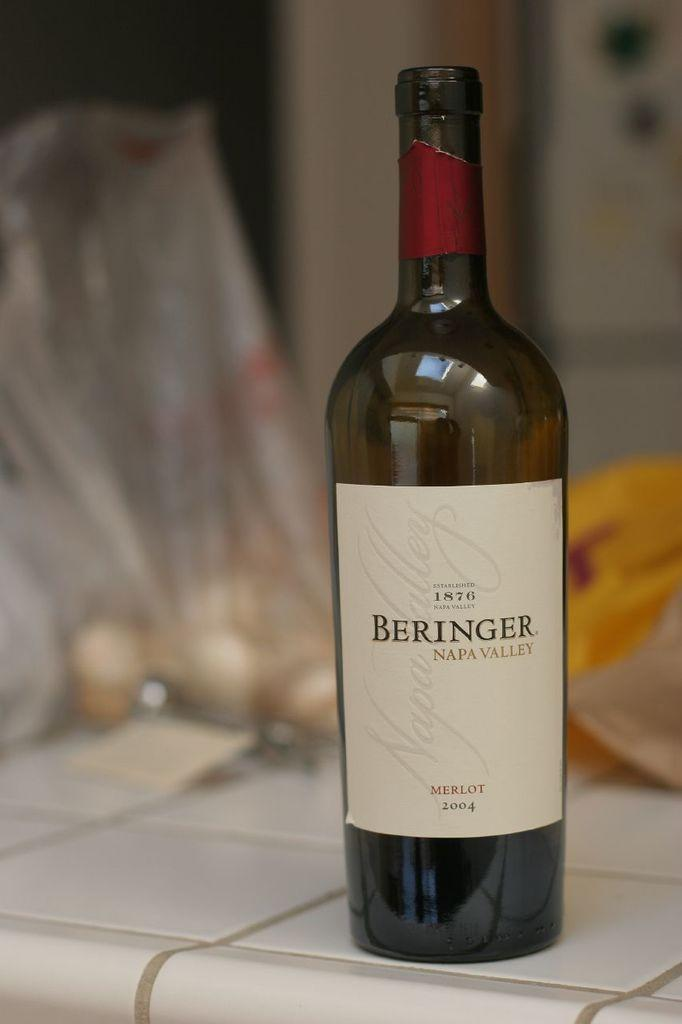<image>
Provide a brief description of the given image. An open bottle of Beringer wine sits on a tile counter 